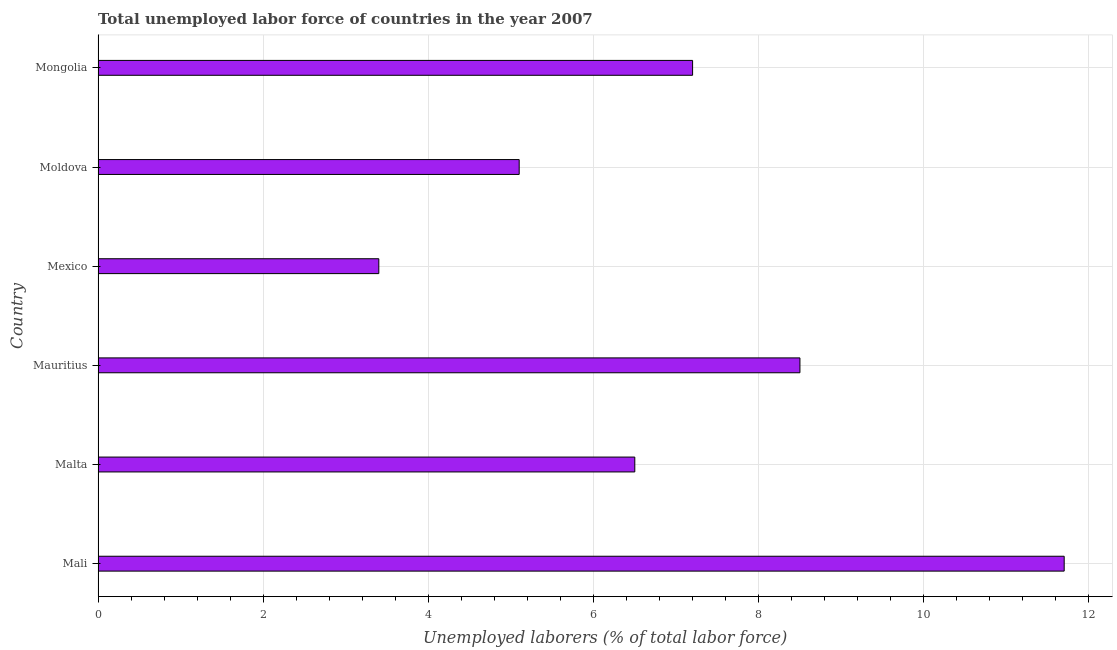Does the graph contain any zero values?
Provide a short and direct response. No. What is the title of the graph?
Give a very brief answer. Total unemployed labor force of countries in the year 2007. What is the label or title of the X-axis?
Keep it short and to the point. Unemployed laborers (% of total labor force). What is the label or title of the Y-axis?
Provide a short and direct response. Country. What is the total unemployed labour force in Mongolia?
Keep it short and to the point. 7.2. Across all countries, what is the maximum total unemployed labour force?
Provide a succinct answer. 11.7. Across all countries, what is the minimum total unemployed labour force?
Provide a short and direct response. 3.4. In which country was the total unemployed labour force maximum?
Offer a terse response. Mali. In which country was the total unemployed labour force minimum?
Your answer should be very brief. Mexico. What is the sum of the total unemployed labour force?
Offer a terse response. 42.4. What is the difference between the total unemployed labour force in Mali and Mexico?
Provide a short and direct response. 8.3. What is the average total unemployed labour force per country?
Provide a succinct answer. 7.07. What is the median total unemployed labour force?
Give a very brief answer. 6.85. In how many countries, is the total unemployed labour force greater than 10 %?
Offer a terse response. 1. What is the ratio of the total unemployed labour force in Mali to that in Mongolia?
Offer a terse response. 1.62. Is the difference between the total unemployed labour force in Mauritius and Moldova greater than the difference between any two countries?
Provide a succinct answer. No. What is the difference between the highest and the second highest total unemployed labour force?
Ensure brevity in your answer.  3.2. Is the sum of the total unemployed labour force in Mali and Mexico greater than the maximum total unemployed labour force across all countries?
Offer a very short reply. Yes. What is the difference between the highest and the lowest total unemployed labour force?
Your response must be concise. 8.3. How many countries are there in the graph?
Provide a succinct answer. 6. What is the Unemployed laborers (% of total labor force) in Mali?
Your answer should be compact. 11.7. What is the Unemployed laborers (% of total labor force) of Malta?
Keep it short and to the point. 6.5. What is the Unemployed laborers (% of total labor force) in Mexico?
Your answer should be very brief. 3.4. What is the Unemployed laborers (% of total labor force) of Moldova?
Give a very brief answer. 5.1. What is the Unemployed laborers (% of total labor force) in Mongolia?
Provide a short and direct response. 7.2. What is the difference between the Unemployed laborers (% of total labor force) in Mali and Malta?
Make the answer very short. 5.2. What is the difference between the Unemployed laborers (% of total labor force) in Mali and Mauritius?
Keep it short and to the point. 3.2. What is the difference between the Unemployed laborers (% of total labor force) in Mali and Moldova?
Provide a short and direct response. 6.6. What is the difference between the Unemployed laborers (% of total labor force) in Malta and Moldova?
Make the answer very short. 1.4. What is the difference between the Unemployed laborers (% of total labor force) in Mauritius and Mexico?
Make the answer very short. 5.1. What is the difference between the Unemployed laborers (% of total labor force) in Mauritius and Moldova?
Provide a succinct answer. 3.4. What is the difference between the Unemployed laborers (% of total labor force) in Moldova and Mongolia?
Give a very brief answer. -2.1. What is the ratio of the Unemployed laborers (% of total labor force) in Mali to that in Malta?
Provide a short and direct response. 1.8. What is the ratio of the Unemployed laborers (% of total labor force) in Mali to that in Mauritius?
Keep it short and to the point. 1.38. What is the ratio of the Unemployed laborers (% of total labor force) in Mali to that in Mexico?
Ensure brevity in your answer.  3.44. What is the ratio of the Unemployed laborers (% of total labor force) in Mali to that in Moldova?
Offer a very short reply. 2.29. What is the ratio of the Unemployed laborers (% of total labor force) in Mali to that in Mongolia?
Provide a succinct answer. 1.62. What is the ratio of the Unemployed laborers (% of total labor force) in Malta to that in Mauritius?
Provide a succinct answer. 0.77. What is the ratio of the Unemployed laborers (% of total labor force) in Malta to that in Mexico?
Make the answer very short. 1.91. What is the ratio of the Unemployed laborers (% of total labor force) in Malta to that in Moldova?
Your answer should be very brief. 1.27. What is the ratio of the Unemployed laborers (% of total labor force) in Malta to that in Mongolia?
Your answer should be compact. 0.9. What is the ratio of the Unemployed laborers (% of total labor force) in Mauritius to that in Moldova?
Your answer should be compact. 1.67. What is the ratio of the Unemployed laborers (% of total labor force) in Mauritius to that in Mongolia?
Make the answer very short. 1.18. What is the ratio of the Unemployed laborers (% of total labor force) in Mexico to that in Moldova?
Provide a succinct answer. 0.67. What is the ratio of the Unemployed laborers (% of total labor force) in Mexico to that in Mongolia?
Provide a succinct answer. 0.47. What is the ratio of the Unemployed laborers (% of total labor force) in Moldova to that in Mongolia?
Offer a very short reply. 0.71. 